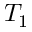<formula> <loc_0><loc_0><loc_500><loc_500>T _ { 1 }</formula> 